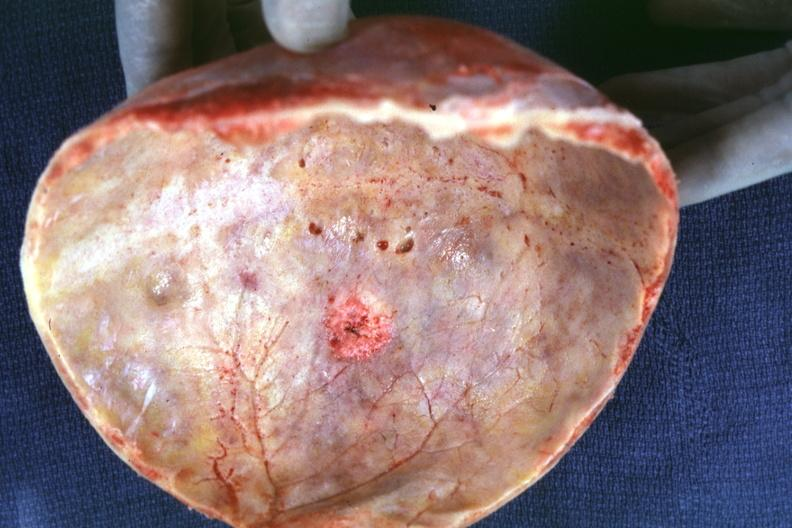what seen on inner table prostate primary?
Answer the question using a single word or phrase. Skull cap with obvious metastatic lesion 